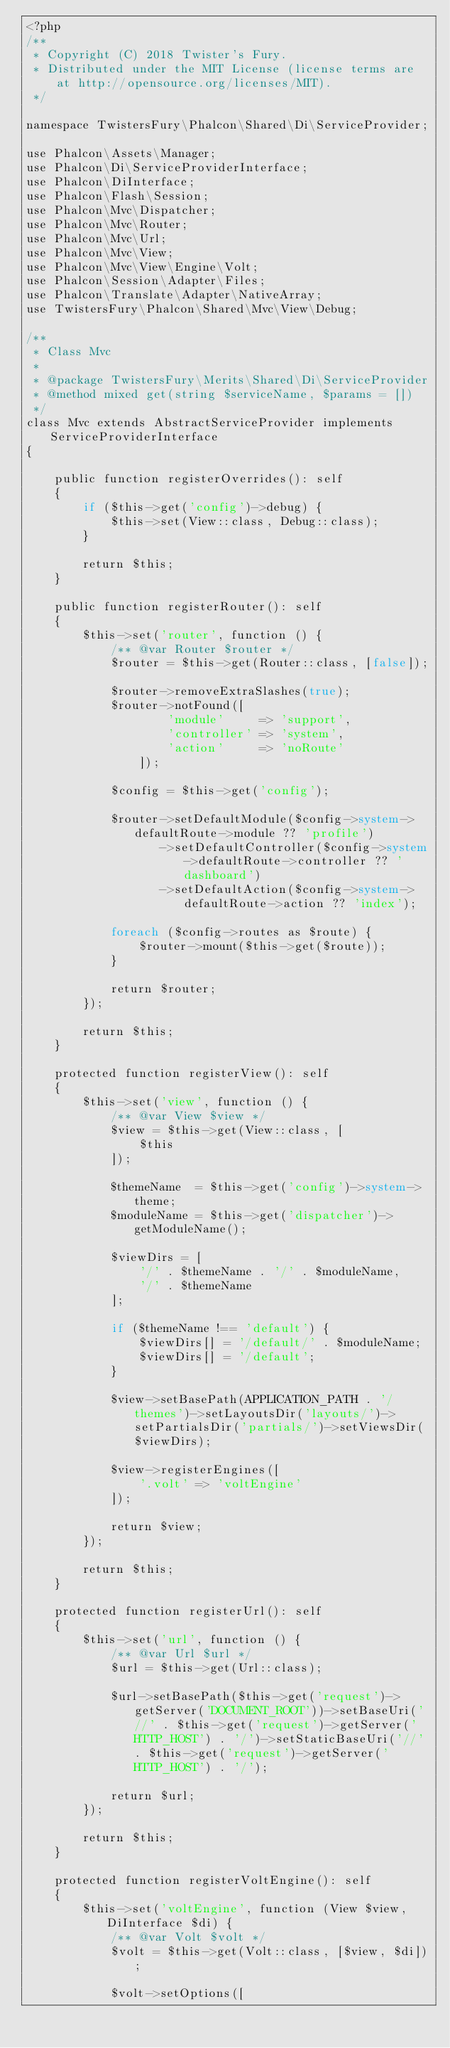Convert code to text. <code><loc_0><loc_0><loc_500><loc_500><_PHP_><?php
/**
 * Copyright (C) 2018 Twister's Fury.
 * Distributed under the MIT License (license terms are at http://opensource.org/licenses/MIT).
 */

namespace TwistersFury\Phalcon\Shared\Di\ServiceProvider;

use Phalcon\Assets\Manager;
use Phalcon\Di\ServiceProviderInterface;
use Phalcon\DiInterface;
use Phalcon\Flash\Session;
use Phalcon\Mvc\Dispatcher;
use Phalcon\Mvc\Router;
use Phalcon\Mvc\Url;
use Phalcon\Mvc\View;
use Phalcon\Mvc\View\Engine\Volt;
use Phalcon\Session\Adapter\Files;
use Phalcon\Translate\Adapter\NativeArray;
use TwistersFury\Phalcon\Shared\Mvc\View\Debug;

/**
 * Class Mvc
 *
 * @package TwistersFury\Merits\Shared\Di\ServiceProvider
 * @method mixed get(string $serviceName, $params = [])
 */
class Mvc extends AbstractServiceProvider implements ServiceProviderInterface
{

    public function registerOverrides(): self
    {
        if ($this->get('config')->debug) {
            $this->set(View::class, Debug::class);
        }

        return $this;
    }

    public function registerRouter(): self
    {
        $this->set('router', function () {
            /** @var Router $router */
            $router = $this->get(Router::class, [false]);

            $router->removeExtraSlashes(true);
            $router->notFound([
                    'module'     => 'support',
                    'controller' => 'system',
                    'action'     => 'noRoute'
                ]);

            $config = $this->get('config');

            $router->setDefaultModule($config->system->defaultRoute->module ?? 'profile')
                   ->setDefaultController($config->system->defaultRoute->controller ?? 'dashboard')
                   ->setDefaultAction($config->system->defaultRoute->action ?? 'index');

            foreach ($config->routes as $route) {
                $router->mount($this->get($route));
            }

            return $router;
        });

        return $this;
    }

    protected function registerView(): self
    {
        $this->set('view', function () {
            /** @var View $view */
            $view = $this->get(View::class, [
                $this
            ]);

            $themeName  = $this->get('config')->system->theme;
            $moduleName = $this->get('dispatcher')->getModuleName();

            $viewDirs = [
                '/' . $themeName . '/' . $moduleName,
                '/' . $themeName
            ];

            if ($themeName !== 'default') {
                $viewDirs[] = '/default/' . $moduleName;
                $viewDirs[] = '/default';
            }

            $view->setBasePath(APPLICATION_PATH . '/themes')->setLayoutsDir('layouts/')->setPartialsDir('partials/')->setViewsDir($viewDirs);

            $view->registerEngines([
                '.volt' => 'voltEngine'
            ]);

            return $view;
        });

        return $this;
    }

    protected function registerUrl(): self
    {
        $this->set('url', function () {
            /** @var Url $url */
            $url = $this->get(Url::class);

            $url->setBasePath($this->get('request')->getServer('DOCUMENT_ROOT'))->setBaseUri('//' . $this->get('request')->getServer('HTTP_HOST') . '/')->setStaticBaseUri('//' . $this->get('request')->getServer('HTTP_HOST') . '/');

            return $url;
        });

        return $this;
    }

    protected function registerVoltEngine(): self
    {
        $this->set('voltEngine', function (View $view, DiInterface $di) {
            /** @var Volt $volt */
            $volt = $this->get(Volt::class, [$view, $di]);

            $volt->setOptions([</code> 